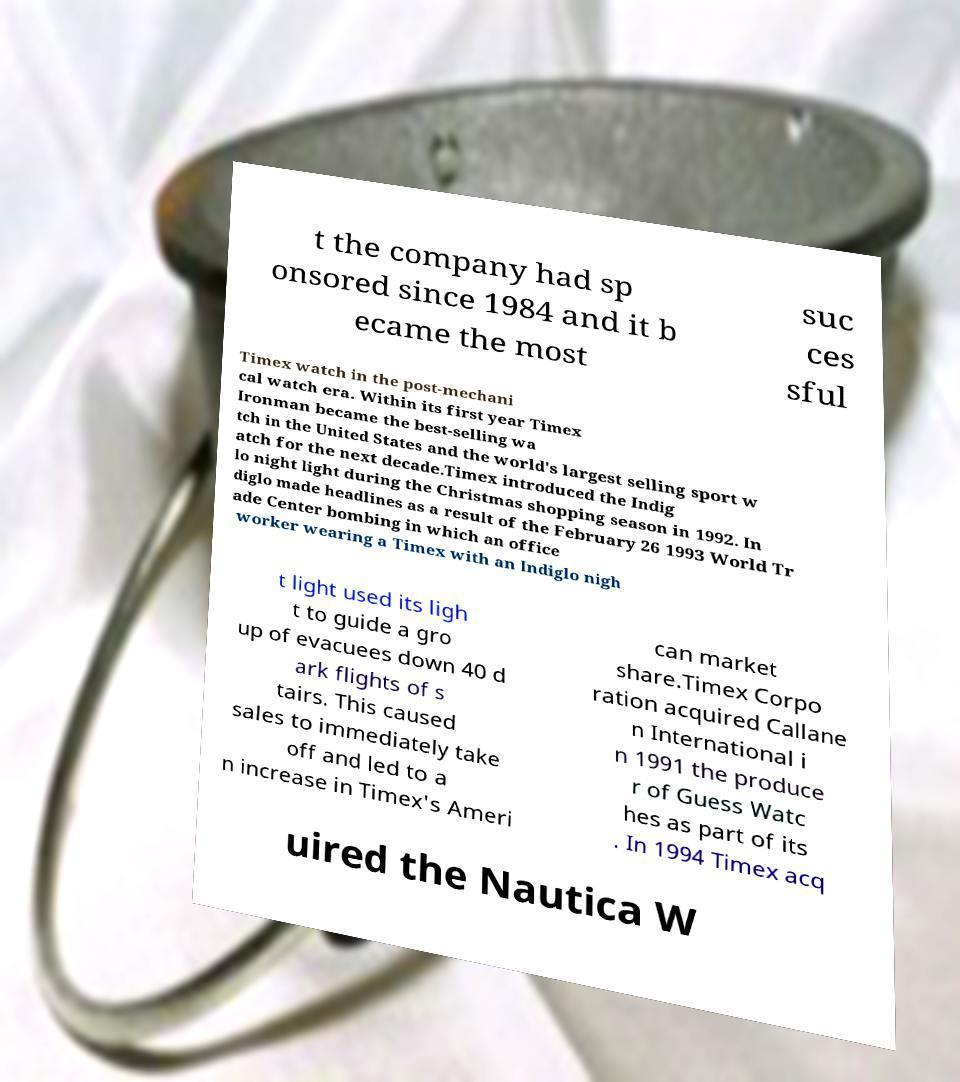I need the written content from this picture converted into text. Can you do that? t the company had sp onsored since 1984 and it b ecame the most suc ces sful Timex watch in the post-mechani cal watch era. Within its first year Timex Ironman became the best-selling wa tch in the United States and the world's largest selling sport w atch for the next decade.Timex introduced the Indig lo night light during the Christmas shopping season in 1992. In diglo made headlines as a result of the February 26 1993 World Tr ade Center bombing in which an office worker wearing a Timex with an Indiglo nigh t light used its ligh t to guide a gro up of evacuees down 40 d ark flights of s tairs. This caused sales to immediately take off and led to a n increase in Timex's Ameri can market share.Timex Corpo ration acquired Callane n International i n 1991 the produce r of Guess Watc hes as part of its . In 1994 Timex acq uired the Nautica W 